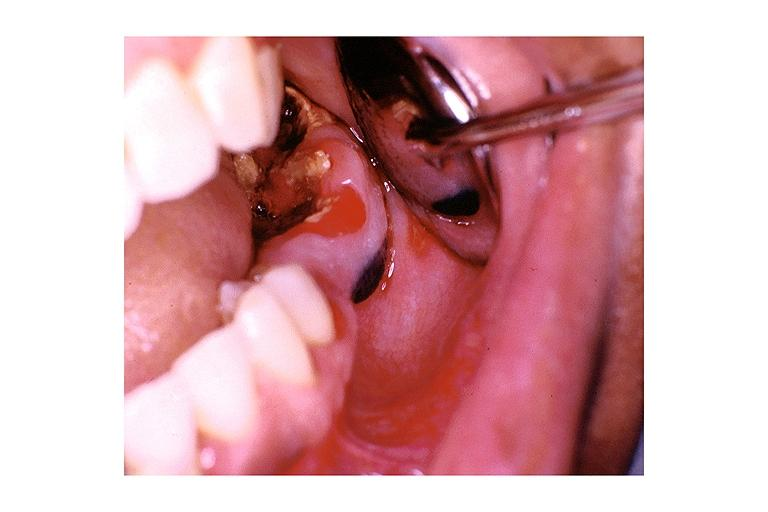does schwannoma show nevus?
Answer the question using a single word or phrase. No 